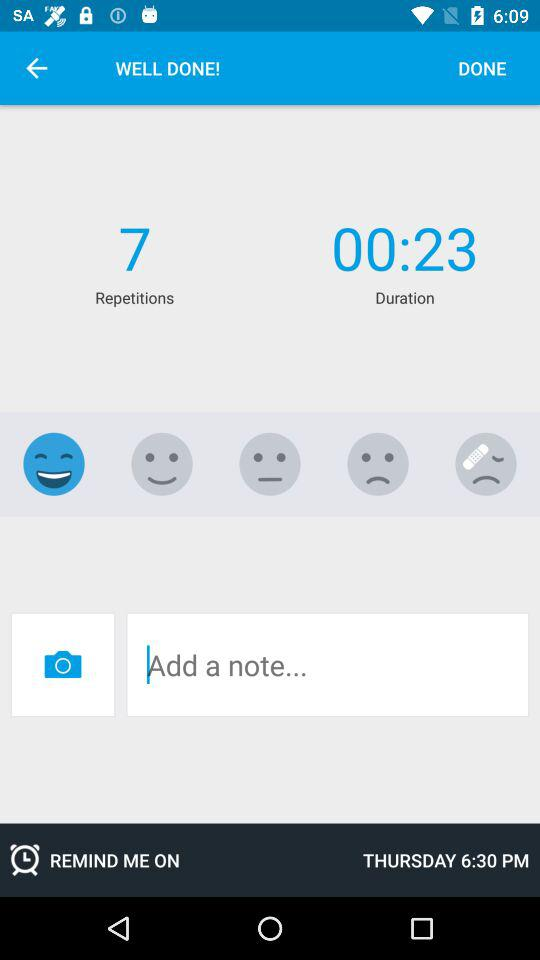Which day is the reminder set for? The reminder is set for Thursday. 